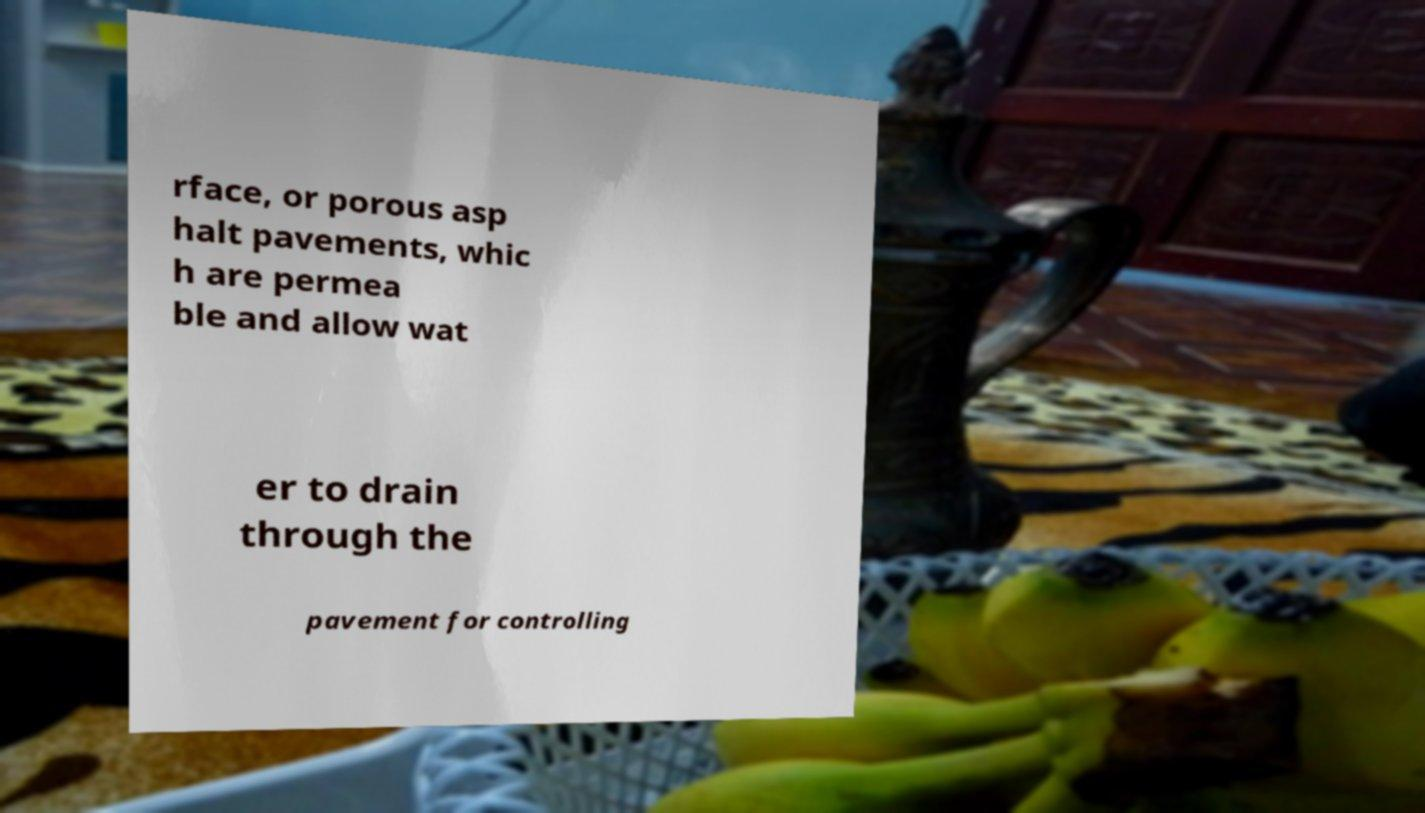Can you read and provide the text displayed in the image?This photo seems to have some interesting text. Can you extract and type it out for me? rface, or porous asp halt pavements, whic h are permea ble and allow wat er to drain through the pavement for controlling 